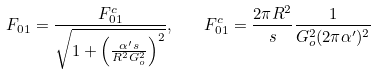Convert formula to latex. <formula><loc_0><loc_0><loc_500><loc_500>F _ { 0 1 } = \frac { F _ { 0 1 } ^ { c } } { \sqrt { 1 + \left ( \frac { \alpha ^ { \prime } s } { R ^ { 2 } G _ { o } ^ { 2 } } \right ) ^ { 2 } } } , \quad F _ { 0 1 } ^ { c } = \frac { 2 \pi R ^ { 2 } } { s } \frac { 1 } { G _ { o } ^ { 2 } ( 2 \pi \alpha ^ { \prime } ) ^ { 2 } }</formula> 